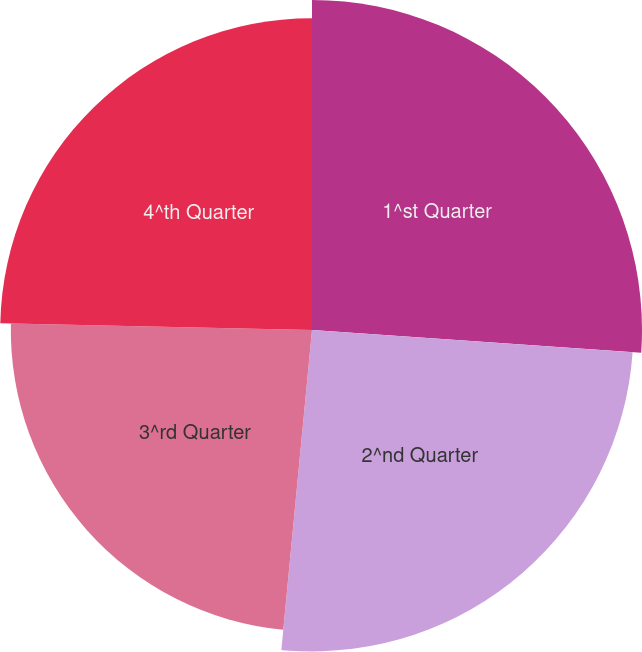Convert chart. <chart><loc_0><loc_0><loc_500><loc_500><pie_chart><fcel>1^st Quarter<fcel>2^nd Quarter<fcel>3^rd Quarter<fcel>4^th Quarter<nl><fcel>26.1%<fcel>25.42%<fcel>23.82%<fcel>24.66%<nl></chart> 